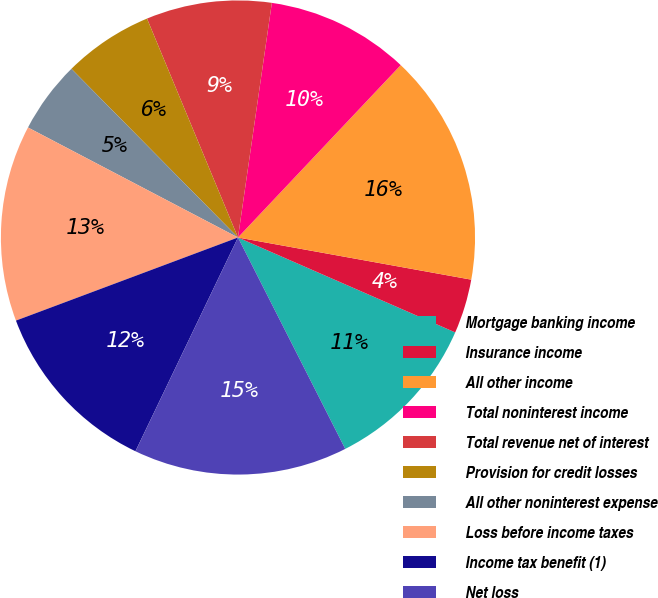Convert chart to OTSL. <chart><loc_0><loc_0><loc_500><loc_500><pie_chart><fcel>Mortgage banking income<fcel>Insurance income<fcel>All other income<fcel>Total noninterest income<fcel>Total revenue net of interest<fcel>Provision for credit losses<fcel>All other noninterest expense<fcel>Loss before income taxes<fcel>Income tax benefit (1)<fcel>Net loss<nl><fcel>10.97%<fcel>3.71%<fcel>15.8%<fcel>9.76%<fcel>8.55%<fcel>6.13%<fcel>4.92%<fcel>13.38%<fcel>12.18%<fcel>14.59%<nl></chart> 